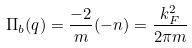Convert formula to latex. <formula><loc_0><loc_0><loc_500><loc_500>\Pi _ { b } ( q ) = \frac { - 2 } { m } ( - n ) = \frac { k ^ { 2 } _ { F } } { 2 \pi m }</formula> 